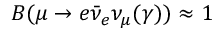<formula> <loc_0><loc_0><loc_500><loc_500>B ( \mu \to e \bar { \nu } _ { e } \nu _ { \mu } ( \gamma ) ) \approx 1</formula> 